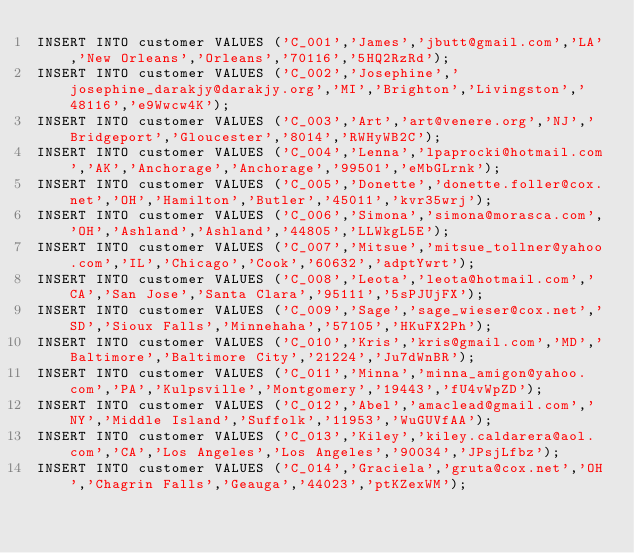<code> <loc_0><loc_0><loc_500><loc_500><_SQL_>INSERT INTO customer VALUES ('C_001','James','jbutt@gmail.com','LA','New Orleans','Orleans','70116','5HQ2RzRd');
INSERT INTO customer VALUES ('C_002','Josephine','josephine_darakjy@darakjy.org','MI','Brighton','Livingston','48116','e9Wwcw4K');
INSERT INTO customer VALUES ('C_003','Art','art@venere.org','NJ','Bridgeport','Gloucester','8014','RWHyWB2C');
INSERT INTO customer VALUES ('C_004','Lenna','lpaprocki@hotmail.com','AK','Anchorage','Anchorage','99501','eMbGLrnk');
INSERT INTO customer VALUES ('C_005','Donette','donette.foller@cox.net','OH','Hamilton','Butler','45011','kvr35wrj');
INSERT INTO customer VALUES ('C_006','Simona','simona@morasca.com','OH','Ashland','Ashland','44805','LLWkgL5E');
INSERT INTO customer VALUES ('C_007','Mitsue','mitsue_tollner@yahoo.com','IL','Chicago','Cook','60632','adptYwrt');
INSERT INTO customer VALUES ('C_008','Leota','leota@hotmail.com','CA','San Jose','Santa Clara','95111','5sPJUjFX');
INSERT INTO customer VALUES ('C_009','Sage','sage_wieser@cox.net','SD','Sioux Falls','Minnehaha','57105','HKuFX2Ph');
INSERT INTO customer VALUES ('C_010','Kris','kris@gmail.com','MD','Baltimore','Baltimore City','21224','Ju7dWnBR');
INSERT INTO customer VALUES ('C_011','Minna','minna_amigon@yahoo.com','PA','Kulpsville','Montgomery','19443','fU4vWpZD');
INSERT INTO customer VALUES ('C_012','Abel','amaclead@gmail.com','NY','Middle Island','Suffolk','11953','WuGUVfAA');
INSERT INTO customer VALUES ('C_013','Kiley','kiley.caldarera@aol.com','CA','Los Angeles','Los Angeles','90034','JPsjLfbz');
INSERT INTO customer VALUES ('C_014','Graciela','gruta@cox.net','OH','Chagrin Falls','Geauga','44023','ptKZexWM');</code> 